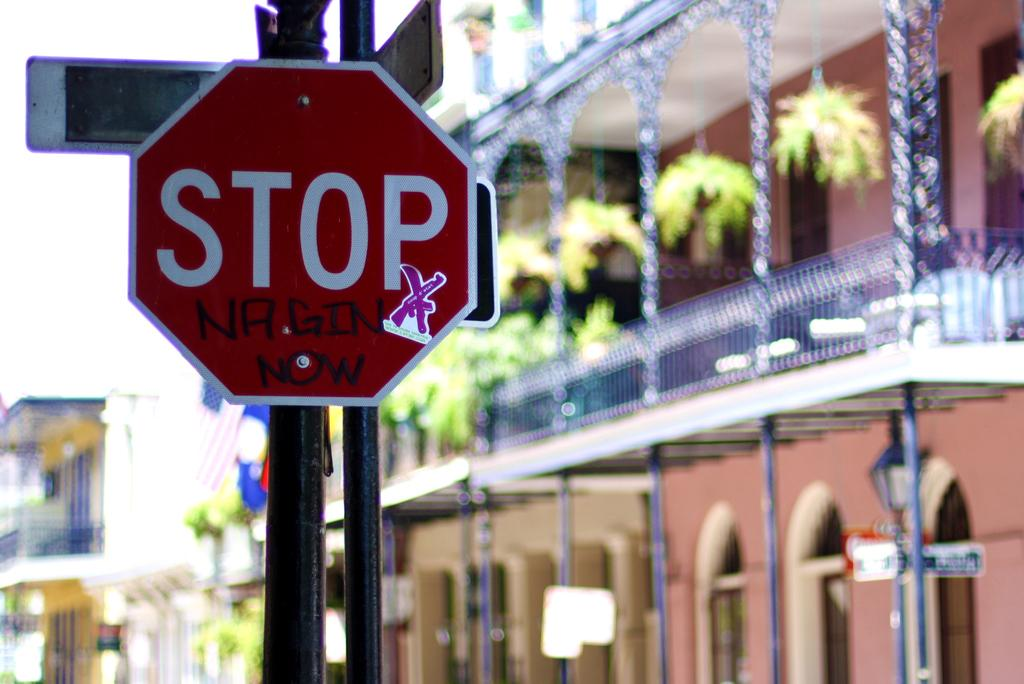<image>
Offer a succinct explanation of the picture presented. A red and white stop sign that has been vandalized wit hmarker and a sticker. 